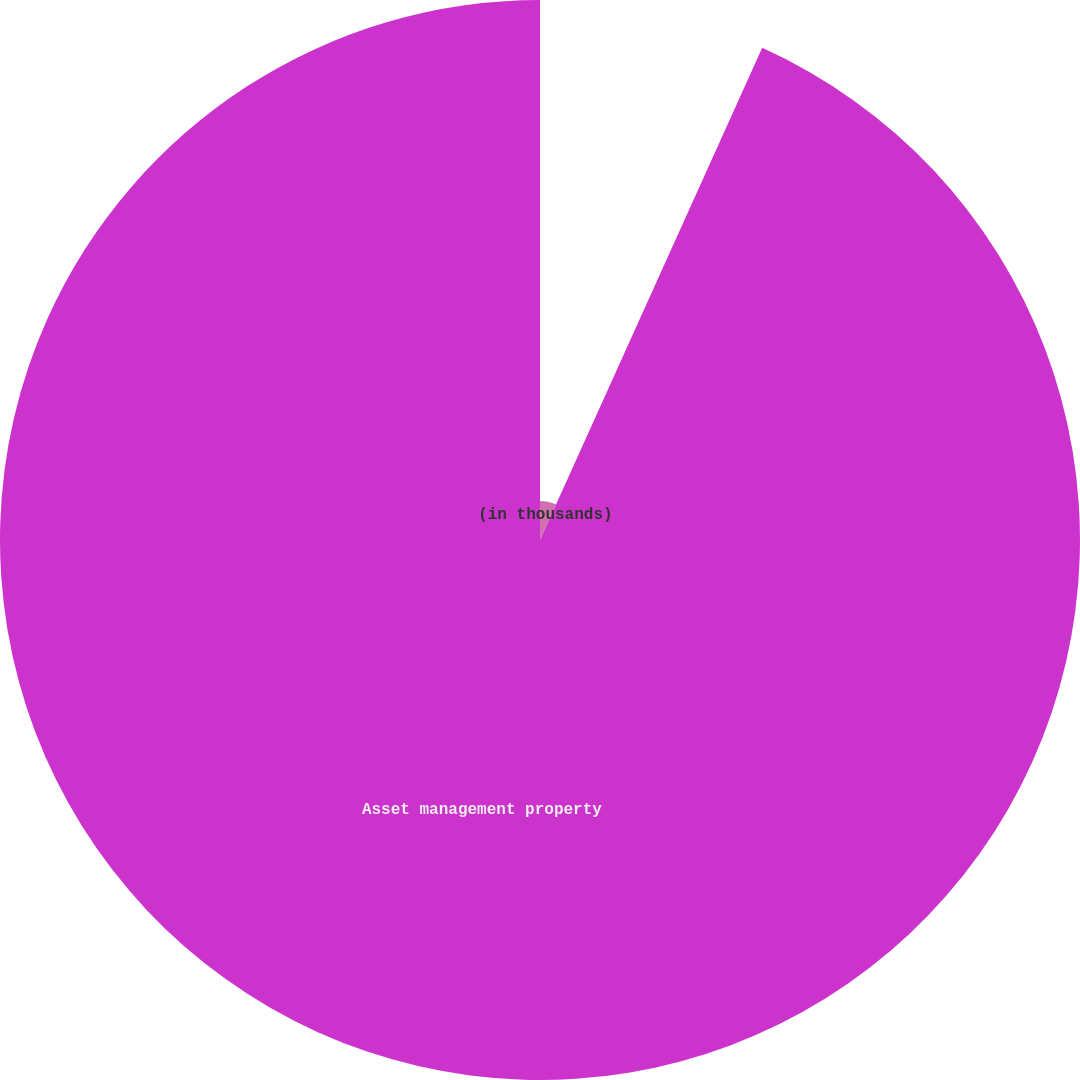Convert chart. <chart><loc_0><loc_0><loc_500><loc_500><pie_chart><fcel>(in thousands)<fcel>Asset management property<nl><fcel>6.75%<fcel>93.25%<nl></chart> 